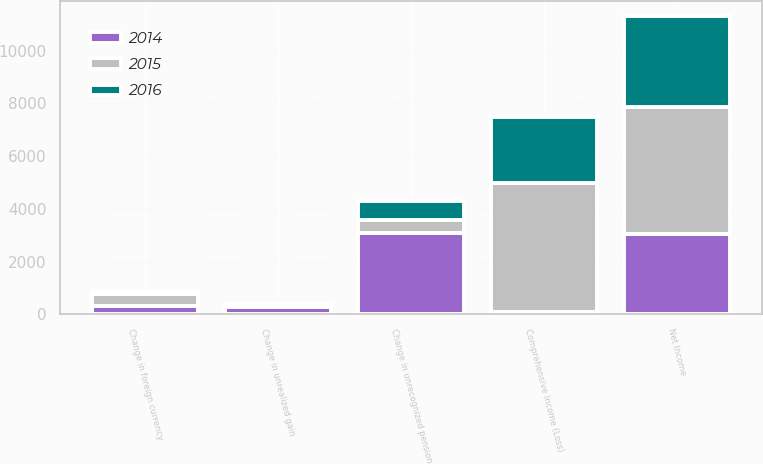Convert chart to OTSL. <chart><loc_0><loc_0><loc_500><loc_500><stacked_bar_chart><ecel><fcel>Net Income<fcel>Change in foreign currency<fcel>Change in unrealized gain<fcel>Change in unrecognized pension<fcel>Comprehensive Income (Loss)<nl><fcel>2016<fcel>3431<fcel>119<fcel>112<fcel>712<fcel>2488<nl><fcel>2015<fcel>4844<fcel>440<fcel>6<fcel>489<fcel>4898<nl><fcel>2014<fcel>3032<fcel>331<fcel>280<fcel>3084<fcel>102<nl></chart> 